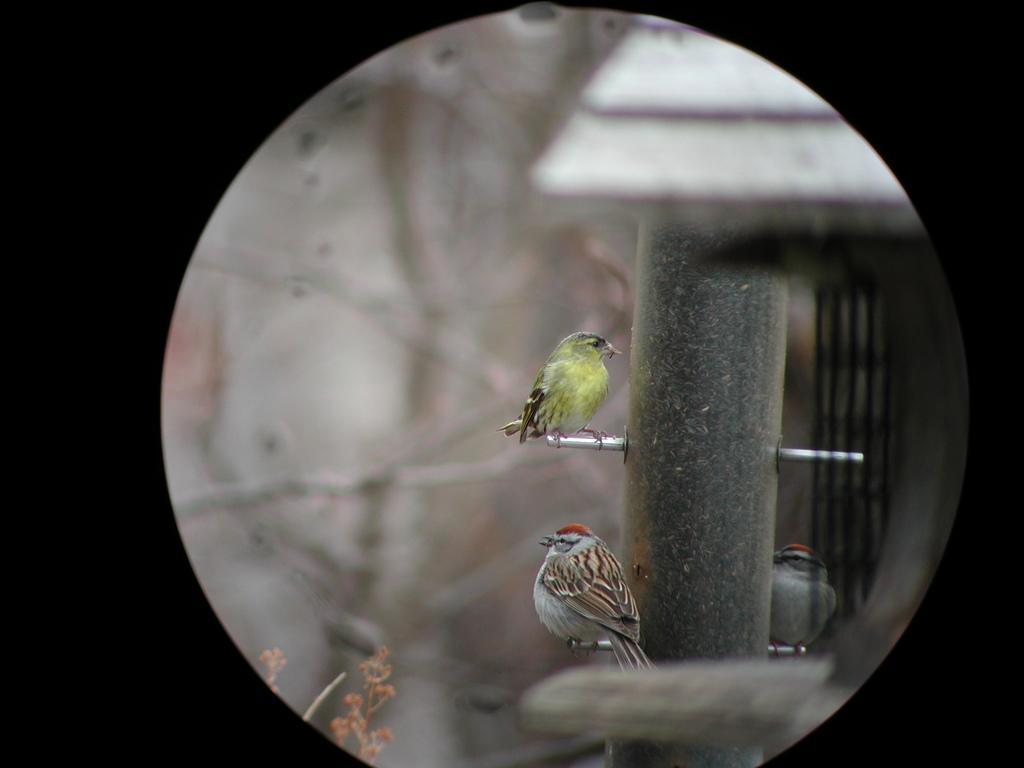Please provide a concise description of this image. Here in this picture we can see a couple of birds standing on a thing that is present on the pole over there. 